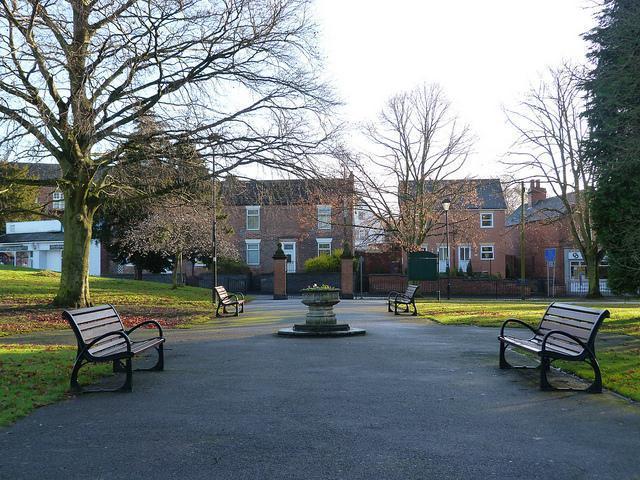How many benches are visible?
Give a very brief answer. 4. How many sentient beings are dogs in this image?
Give a very brief answer. 0. 